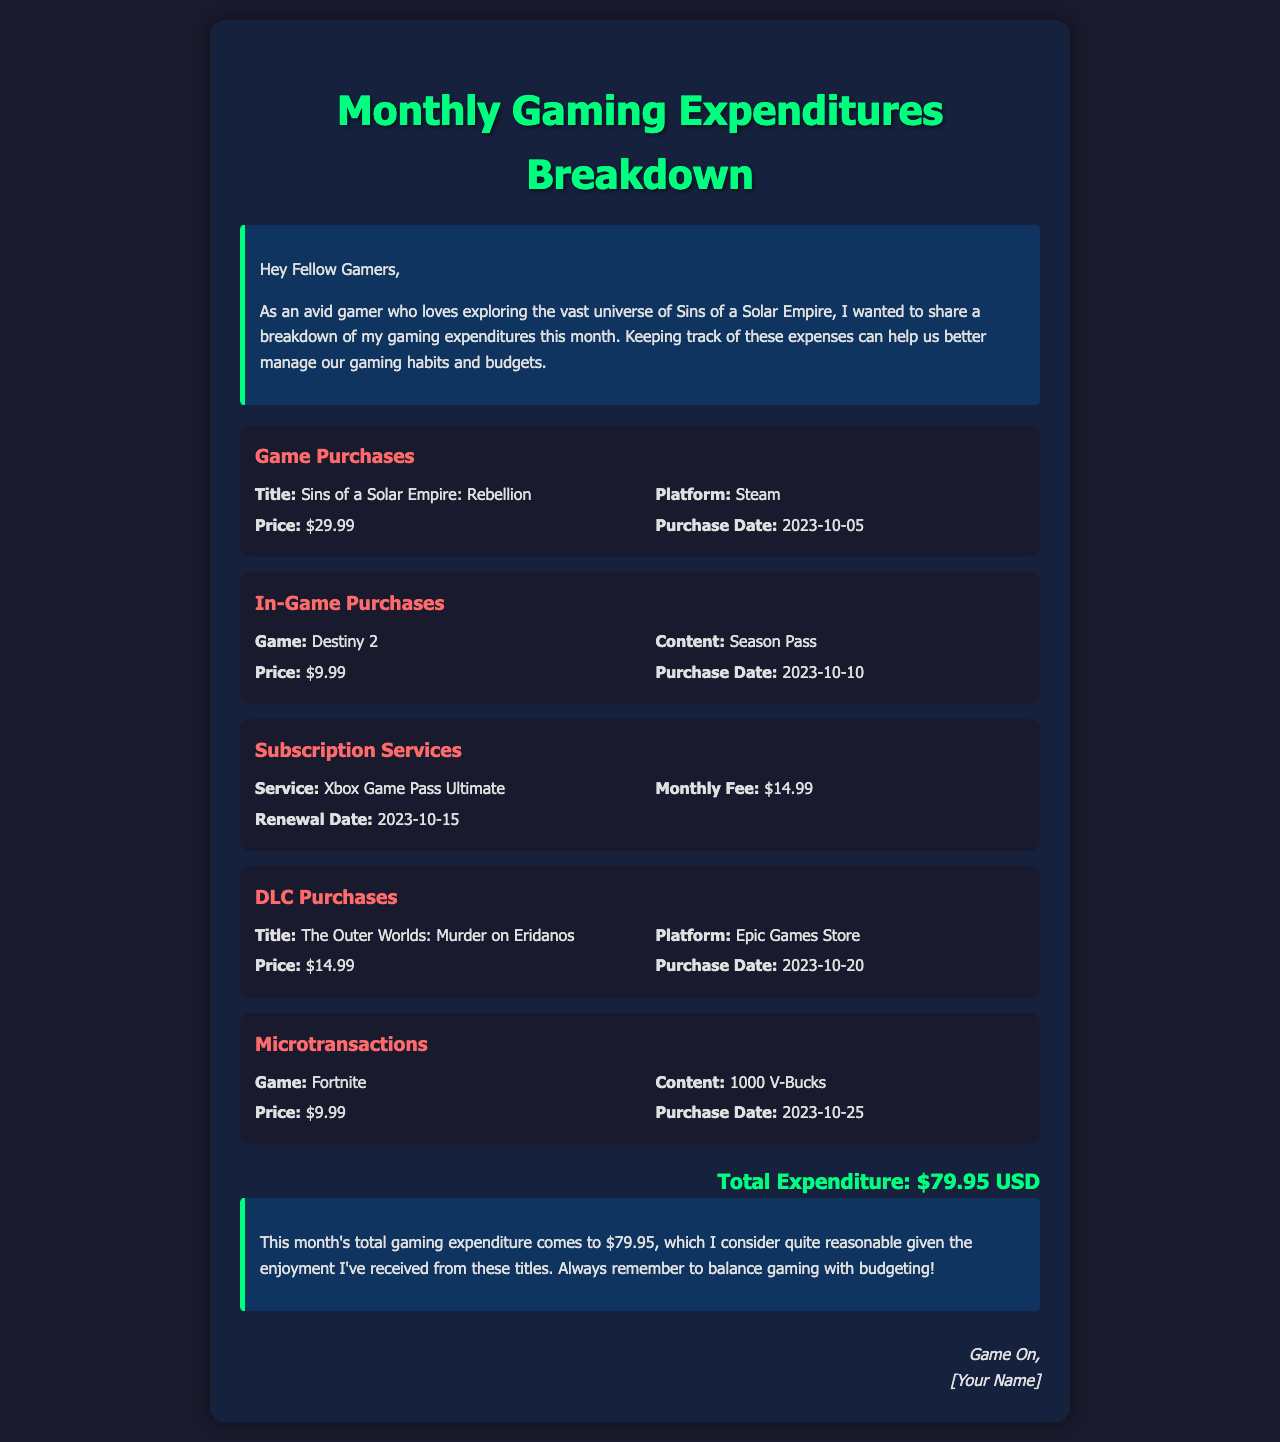What is the total expenditure? The total expenditure is calculated by summing all gaming expenses mentioned in the document.
Answer: $79.95 USD What game was purchased on October 5, 2023? The document lists the game titles and their purchase dates; the game bought on October 5, 2023 is Sins of a Solar Empire: Rebellion.
Answer: Sins of a Solar Empire: Rebellion How much was spent on the Destiny 2 Season Pass? The document specifies the expenditure for the in-game purchase of Season Pass for Destiny 2.
Answer: $9.99 What is the monthly fee for Xbox Game Pass Ultimate? The document lists the subscription services and their fees; the monthly fee for Xbox Game Pass Ultimate is included.
Answer: $14.99 When was the DLC for The Outer Worlds purchased? The document provides purchase dates for all listed expenditures, indicating when the DLC was acquired.
Answer: 2023-10-20 What content was purchased for Fortnite? The details of in-game purchases indicate the specific items obtained and their costs, highlighting the Fortnite microtransaction.
Answer: 1000 V-Bucks Which platform was used to purchase the DLC for The Outer Worlds? The platform for each purchase is mentioned; for the DLC, the specific platform used can be found in the details.
Answer: Epic Games Store How many gaming categories are listed in the document? The breakdown consists of several expenditure categories highlighting different types of expenses.
Answer: 5 What date does the Xbox Game Pass Ultimate subscription renew? The renewal date for the subscription service is specified in the details provided in the document.
Answer: 2023-10-15 